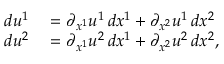<formula> <loc_0><loc_0><loc_500><loc_500>\begin{array} { r l } { d u ^ { 1 } } & = \partial _ { x ^ { 1 } } u ^ { 1 } \, d x ^ { 1 } + \partial _ { x ^ { 2 } } u ^ { 1 } \, d x ^ { 2 } } \\ { d u ^ { 2 } } & = \partial _ { x ^ { 1 } } u ^ { 2 } \, d x ^ { 1 } + \partial _ { x ^ { 2 } } u ^ { 2 } \, d x ^ { 2 } , } \end{array}</formula> 